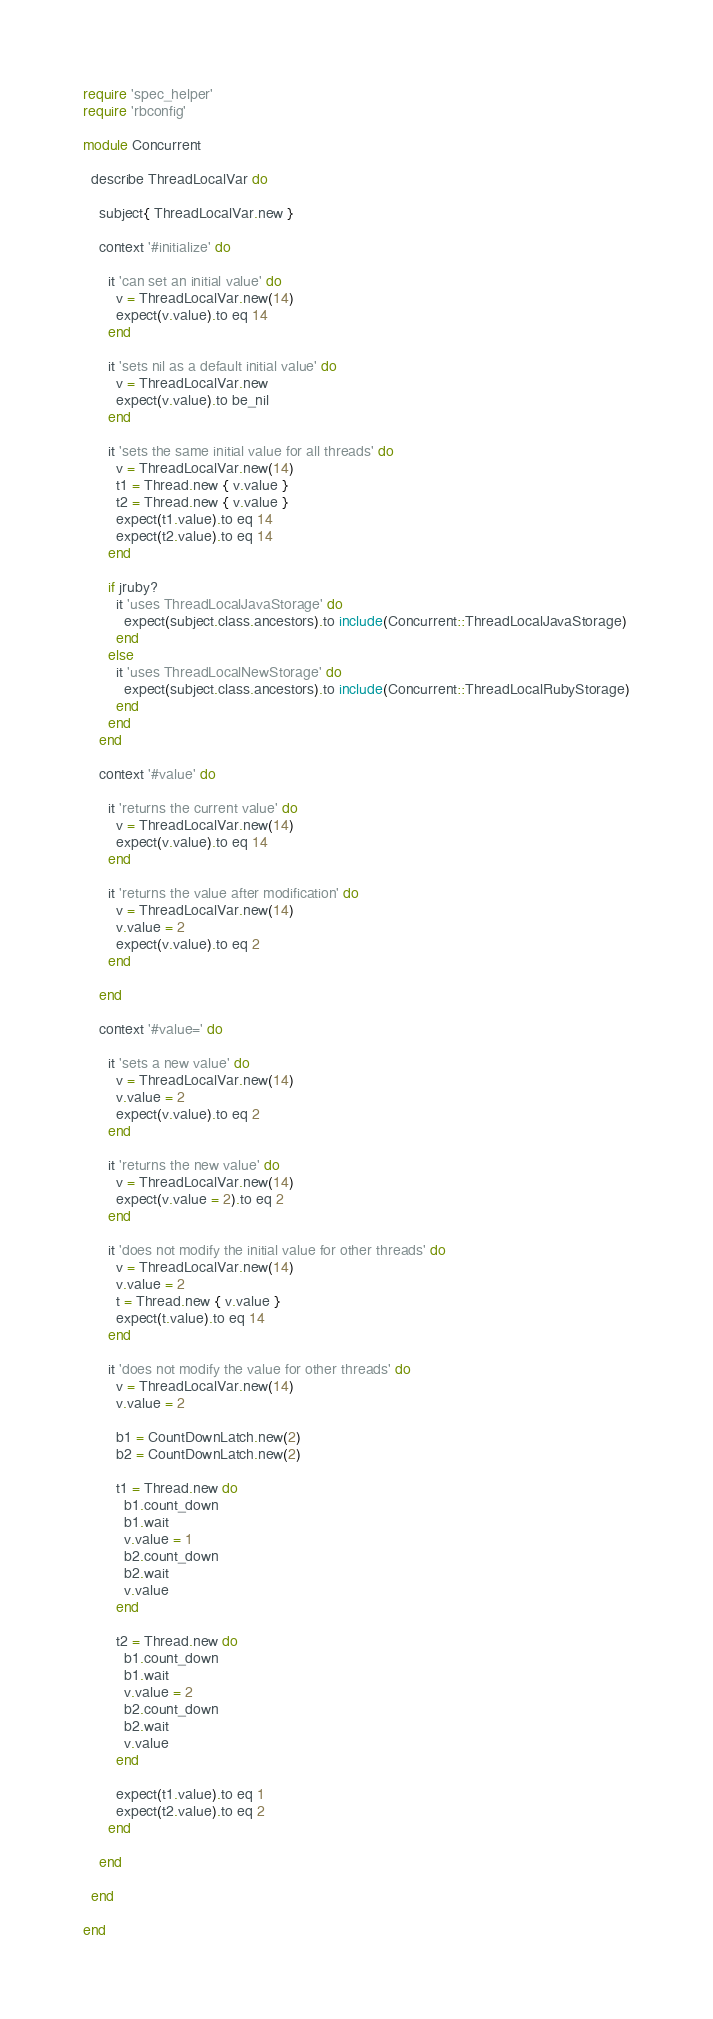<code> <loc_0><loc_0><loc_500><loc_500><_Ruby_>require 'spec_helper'
require 'rbconfig'

module Concurrent

  describe ThreadLocalVar do

    subject{ ThreadLocalVar.new }

    context '#initialize' do

      it 'can set an initial value' do
        v = ThreadLocalVar.new(14)
        expect(v.value).to eq 14
      end

      it 'sets nil as a default initial value' do
        v = ThreadLocalVar.new
        expect(v.value).to be_nil
      end

      it 'sets the same initial value for all threads' do
        v = ThreadLocalVar.new(14)
        t1 = Thread.new { v.value }
        t2 = Thread.new { v.value }
        expect(t1.value).to eq 14
        expect(t2.value).to eq 14
      end

      if jruby?
        it 'uses ThreadLocalJavaStorage' do
          expect(subject.class.ancestors).to include(Concurrent::ThreadLocalJavaStorage)
        end
      else
        it 'uses ThreadLocalNewStorage' do
          expect(subject.class.ancestors).to include(Concurrent::ThreadLocalRubyStorage)
        end
      end
    end

    context '#value' do

      it 'returns the current value' do
        v = ThreadLocalVar.new(14)
        expect(v.value).to eq 14
      end

      it 'returns the value after modification' do
        v = ThreadLocalVar.new(14)
        v.value = 2
        expect(v.value).to eq 2
      end

    end

    context '#value=' do

      it 'sets a new value' do
        v = ThreadLocalVar.new(14)
        v.value = 2
        expect(v.value).to eq 2
      end

      it 'returns the new value' do
        v = ThreadLocalVar.new(14)
        expect(v.value = 2).to eq 2
      end

      it 'does not modify the initial value for other threads' do
        v = ThreadLocalVar.new(14)
        v.value = 2
        t = Thread.new { v.value }
        expect(t.value).to eq 14
      end

      it 'does not modify the value for other threads' do
        v = ThreadLocalVar.new(14)
        v.value = 2

        b1 = CountDownLatch.new(2)
        b2 = CountDownLatch.new(2)

        t1 = Thread.new do
          b1.count_down
          b1.wait
          v.value = 1
          b2.count_down
          b2.wait
          v.value
        end

        t2 = Thread.new do
          b1.count_down
          b1.wait
          v.value = 2
          b2.count_down
          b2.wait
          v.value
        end

        expect(t1.value).to eq 1
        expect(t2.value).to eq 2
      end

    end

  end

end
</code> 